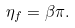Convert formula to latex. <formula><loc_0><loc_0><loc_500><loc_500>\eta _ { f } = \beta \pi .</formula> 